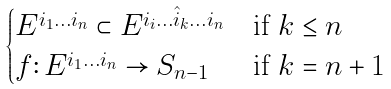Convert formula to latex. <formula><loc_0><loc_0><loc_500><loc_500>\begin{cases} E ^ { i _ { 1 } \dots i _ { n } } \subset E ^ { i _ { i } \dots \hat { i } _ { k } \dots i _ { n } } & \text {if $k\leq n$} \\ f \colon E ^ { i _ { 1 } \dots i _ { n } } \to S _ { n - 1 } & \text {if $k=n+1$} \end{cases}</formula> 